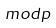<formula> <loc_0><loc_0><loc_500><loc_500>m o d p</formula> 